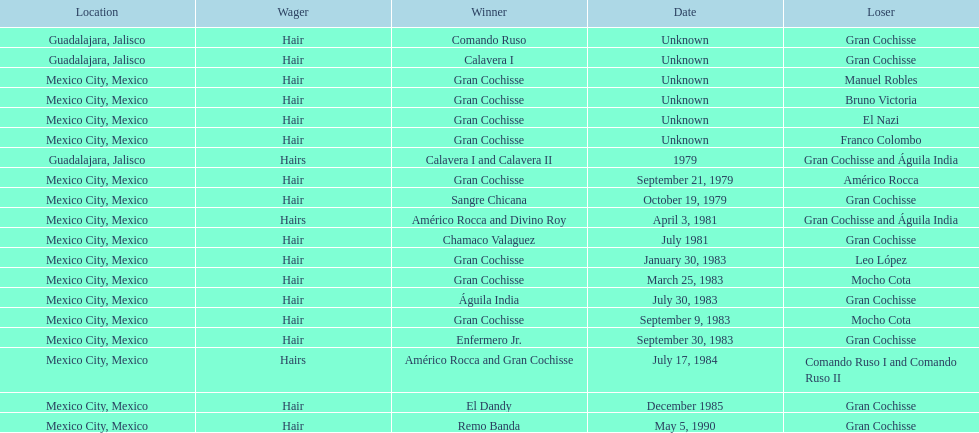How many games more than chamaco valaguez did sangre chicana win? 0. 